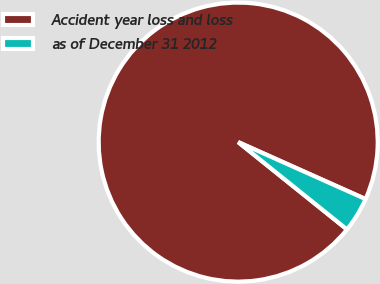Convert chart. <chart><loc_0><loc_0><loc_500><loc_500><pie_chart><fcel>Accident year loss and loss<fcel>as of December 31 2012<nl><fcel>95.93%<fcel>4.07%<nl></chart> 